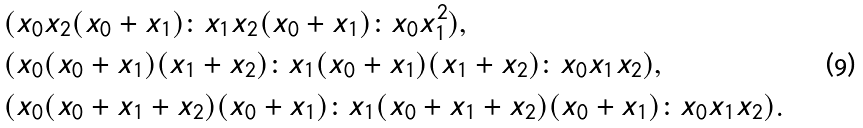Convert formula to latex. <formula><loc_0><loc_0><loc_500><loc_500>& ( x _ { 0 } x _ { 2 } ( x _ { 0 } + x _ { 1 } ) \colon x _ { 1 } x _ { 2 } ( x _ { 0 } + x _ { 1 } ) \colon x _ { 0 } x _ { 1 } ^ { 2 } ) , \\ & ( x _ { 0 } ( x _ { 0 } + x _ { 1 } ) ( x _ { 1 } + x _ { 2 } ) \colon x _ { 1 } ( x _ { 0 } + x _ { 1 } ) ( x _ { 1 } + x _ { 2 } ) \colon x _ { 0 } x _ { 1 } x _ { 2 } ) , \\ & ( x _ { 0 } ( x _ { 0 } + x _ { 1 } + x _ { 2 } ) ( x _ { 0 } + x _ { 1 } ) \colon x _ { 1 } ( x _ { 0 } + x _ { 1 } + x _ { 2 } ) ( x _ { 0 } + x _ { 1 } ) \colon x _ { 0 } x _ { 1 } x _ { 2 } ) .</formula> 